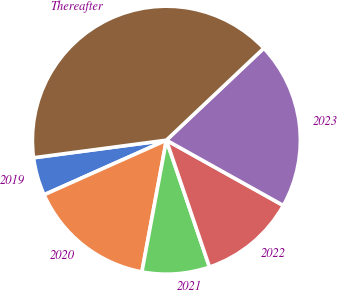Convert chart to OTSL. <chart><loc_0><loc_0><loc_500><loc_500><pie_chart><fcel>2019<fcel>2020<fcel>2021<fcel>2022<fcel>2023<fcel>Thereafter<nl><fcel>4.59%<fcel>15.39%<fcel>8.14%<fcel>11.68%<fcel>20.15%<fcel>40.05%<nl></chart> 